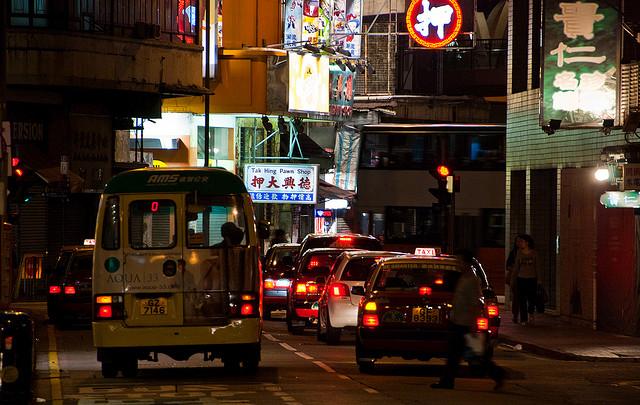Are most of the stores closed on this street?
Short answer required. No. What is the photo taken in the US?
Give a very brief answer. No. What number is the bus?
Answer briefly. 0. How many vehicles are in the picture?
Concise answer only. 7. Is it daytime or night in this photo?
Write a very short answer. Night. 